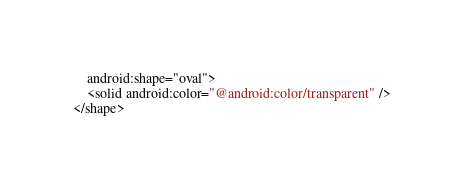Convert code to text. <code><loc_0><loc_0><loc_500><loc_500><_XML_>    android:shape="oval">
    <solid android:color="@android:color/transparent" />
</shape></code> 